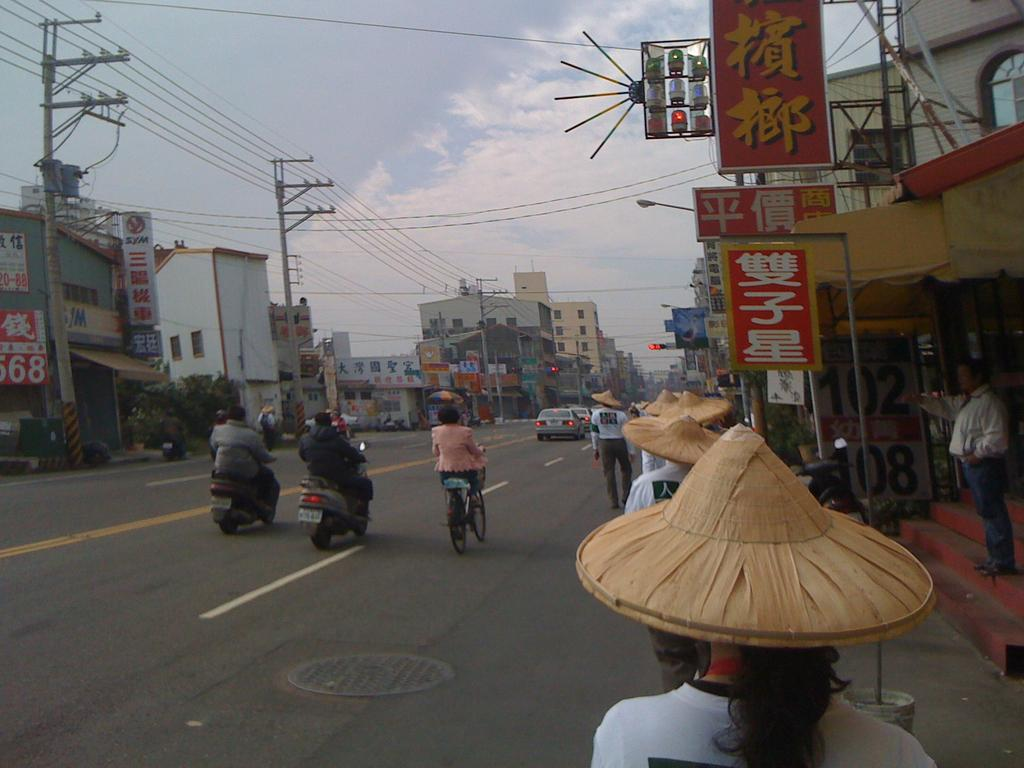<image>
Present a compact description of the photo's key features. A wide asian street with numerous signs, one of which shows the number 102. 